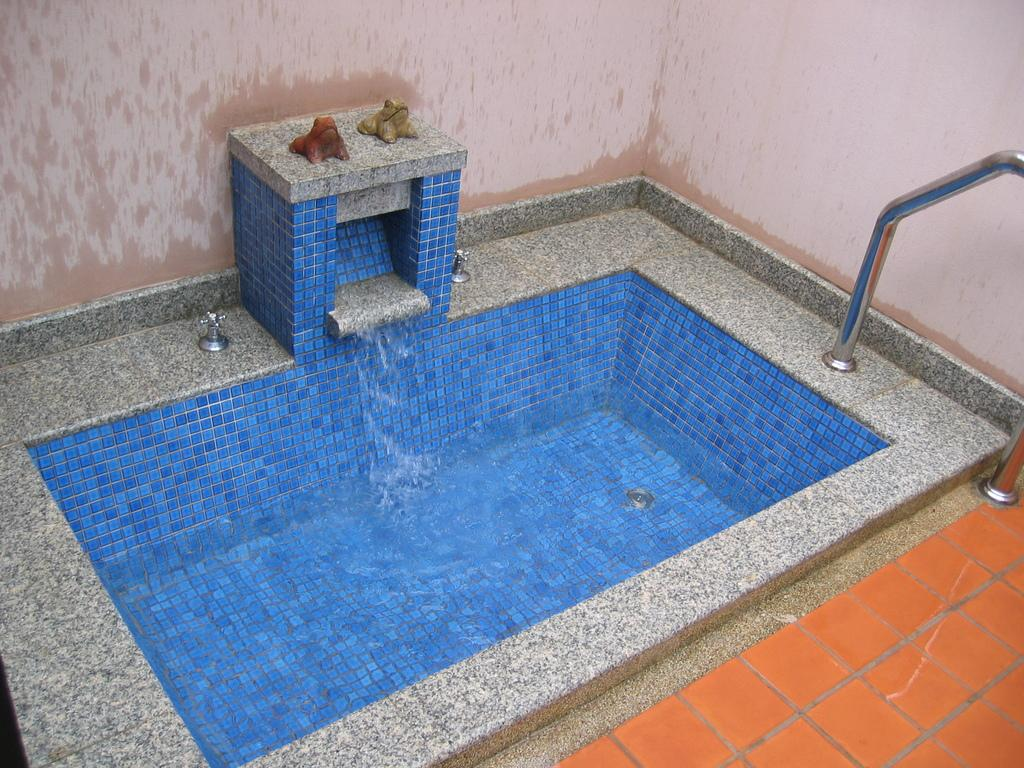What is the main structure visible in the image? There is a concrete tank in the image. What is present inside the tank? There is water in the image. What other objects can be seen in the image? There are objects in the image. What type of material is used for the walls in the image? There are walls in the image made of concrete. What type of material is used for the rods in the image? There are iron rods in the image. What type of flooring is present in the image? There are tiles in the image. What is the cause of the friendship between the two objects in the image? There are no objects in the image that are depicted as friends, and therefore, there is no cause for a friendship between them. 